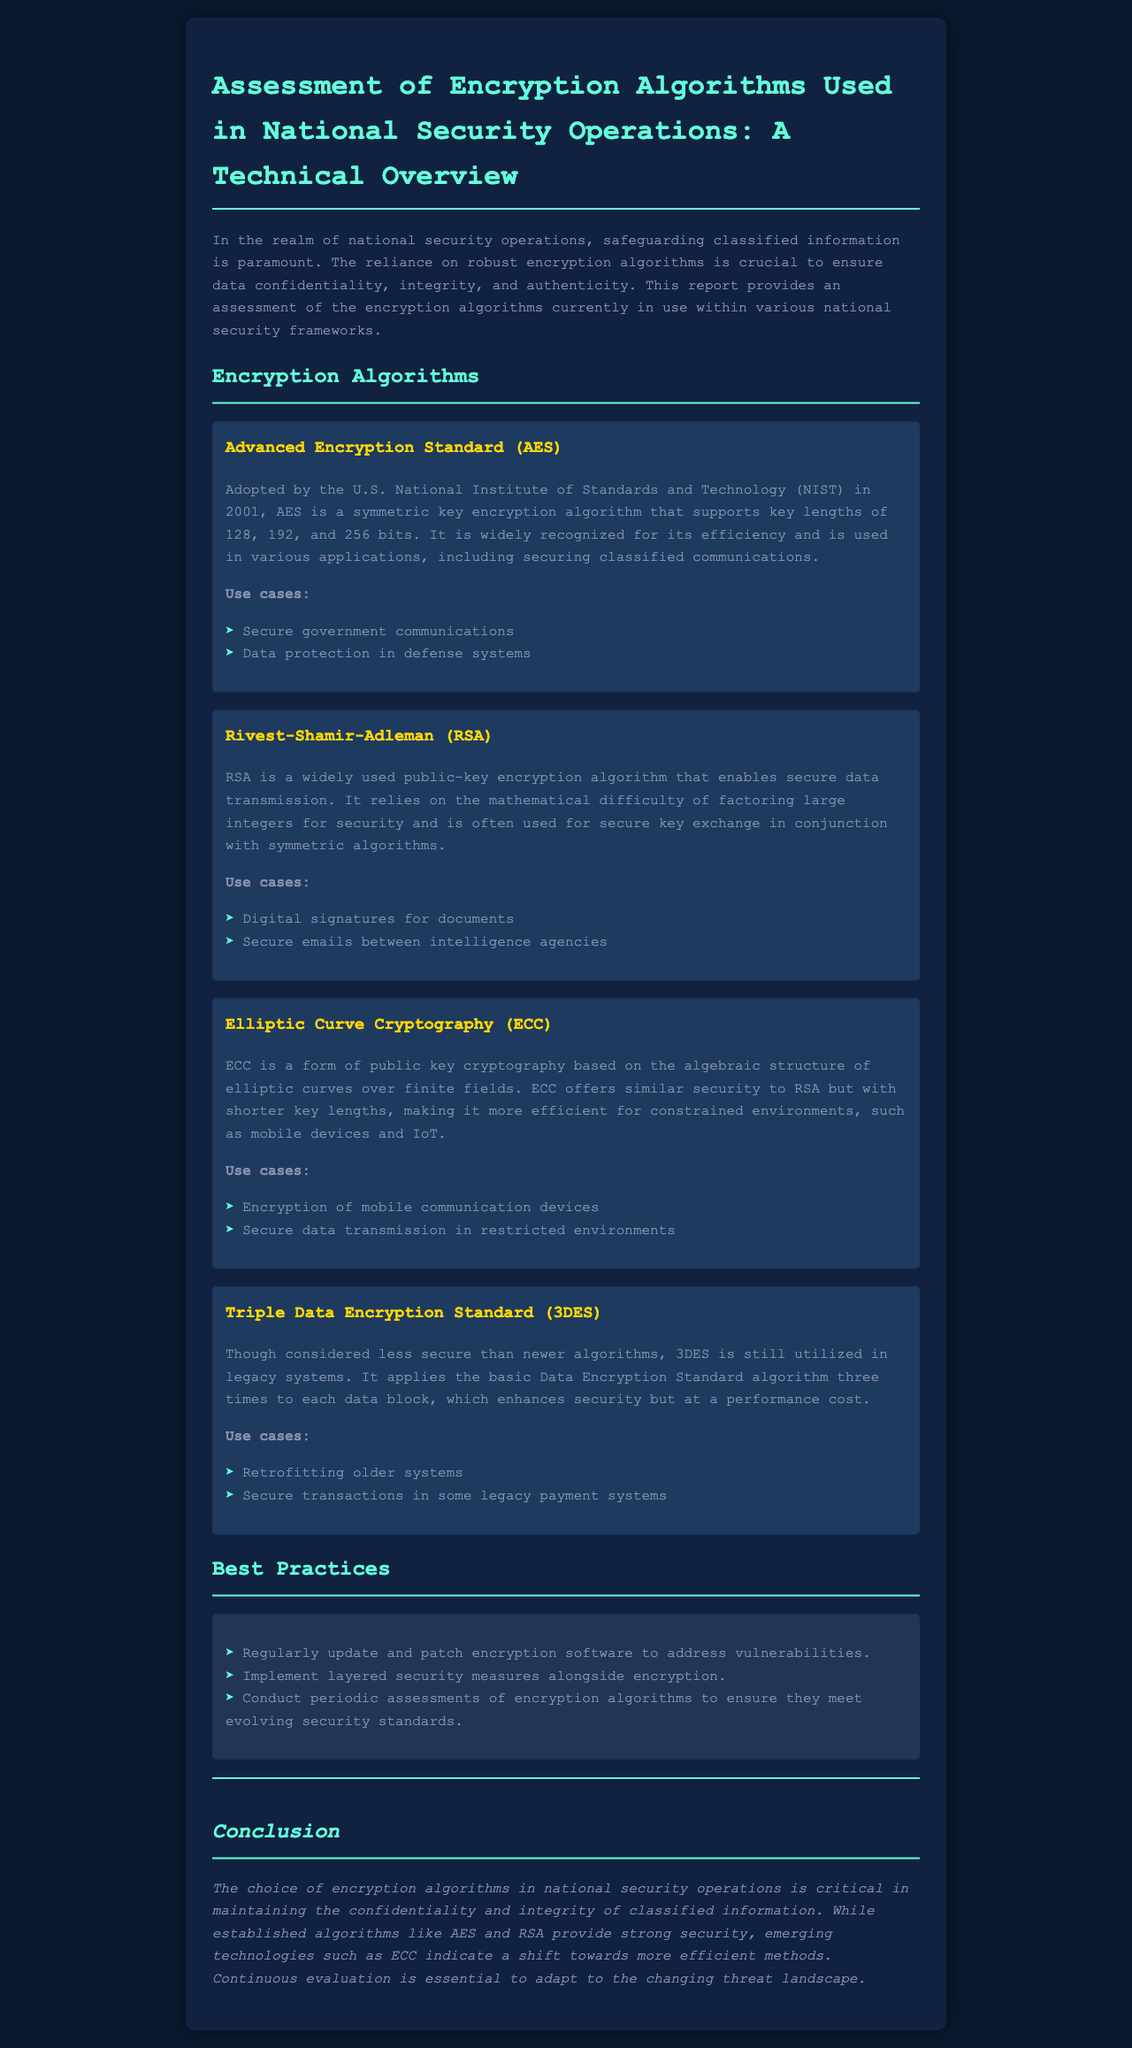What is the title of the report? The title of the report is the main heading in the document.
Answer: Assessment of Encryption Algorithms Used in National Security Operations: A Technical Overview Which algorithm was adopted by NIST in 2001? NIST adopted AES in 2001 as per the document information.
Answer: AES What is the maximum key length supported by AES? The document specifies that AES supports key lengths of 128, 192, and 256 bits.
Answer: 256 bits What cryptographic method does RSA rely on? The document mentions that RSA relies on the mathematical difficulty of factoring large integers for security.
Answer: Factoring large integers Which encryption algorithm is mentioned for use in mobile devices? The document states that ECC is used for encryption of mobile communication devices.
Answer: ECC What is a noted disadvantage of 3DES? The document points out that 3DES is considered less secure than newer algorithms, which serves as its main disadvantage.
Answer: Less secure What should be done regularly to encryption software? The document recommends that encryption software should be regularly updated and patched.
Answer: Regularly update What is the overall importance of choosing encryption algorithms in national security? The document emphasizes the critical role of encryption algorithms in maintaining data confidentiality and integrity.
Answer: Confidentiality and integrity What is a suggested practice alongside encryption? The document advises implementing layered security measures alongside encryption.
Answer: Layered security measures 